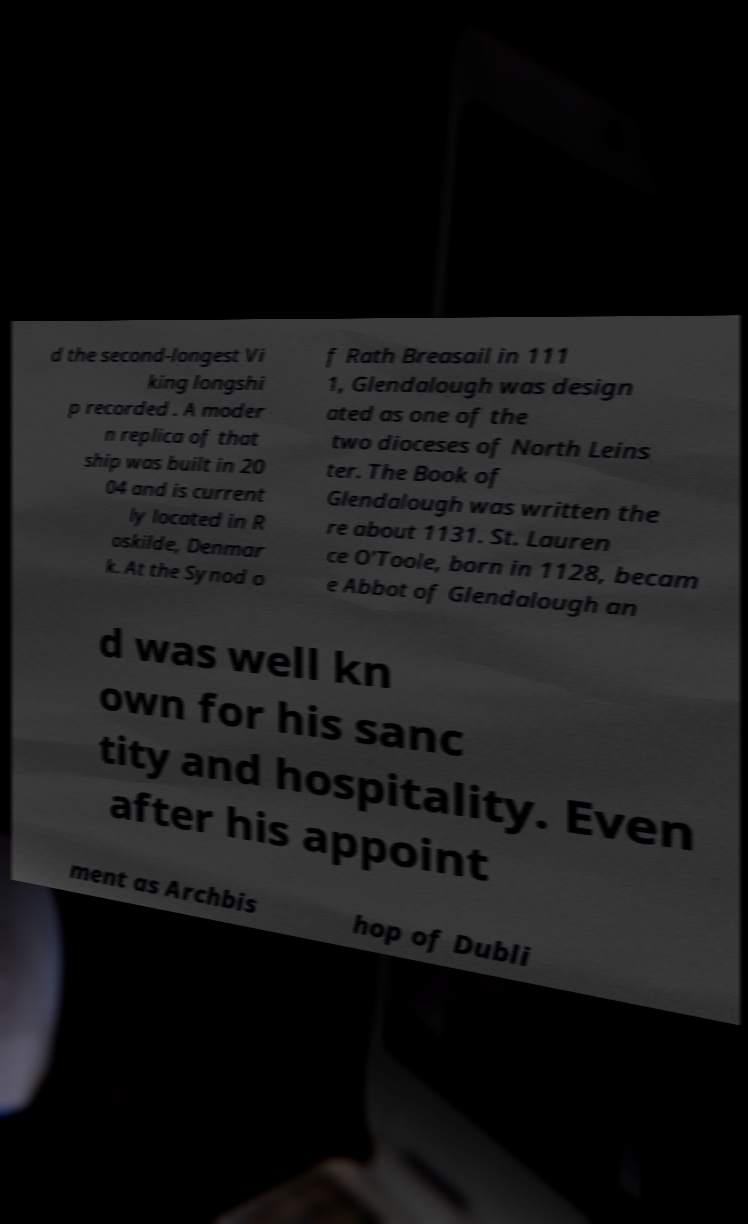Please read and relay the text visible in this image. What does it say? d the second-longest Vi king longshi p recorded . A moder n replica of that ship was built in 20 04 and is current ly located in R oskilde, Denmar k. At the Synod o f Rath Breasail in 111 1, Glendalough was design ated as one of the two dioceses of North Leins ter. The Book of Glendalough was written the re about 1131. St. Lauren ce O'Toole, born in 1128, becam e Abbot of Glendalough an d was well kn own for his sanc tity and hospitality. Even after his appoint ment as Archbis hop of Dubli 